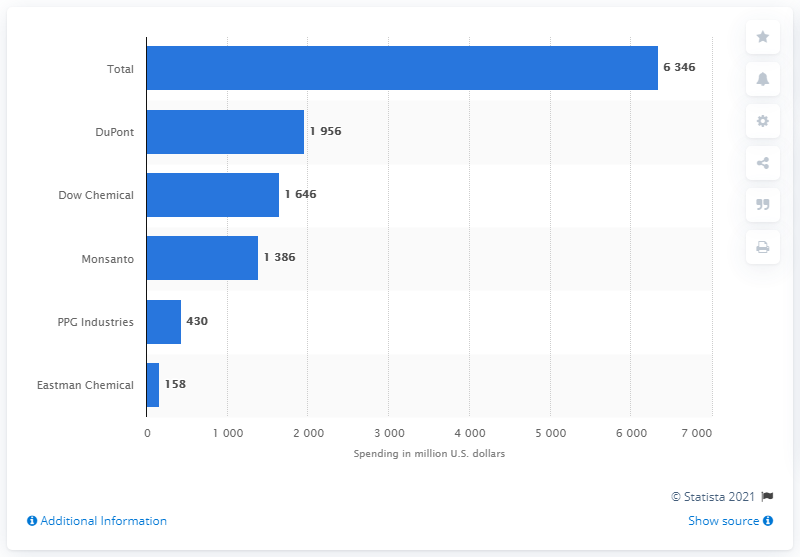Outline some significant characteristics in this image. In 2011, the total spending of the 17 leading chemical companies in the United States was approximately 6,346. 